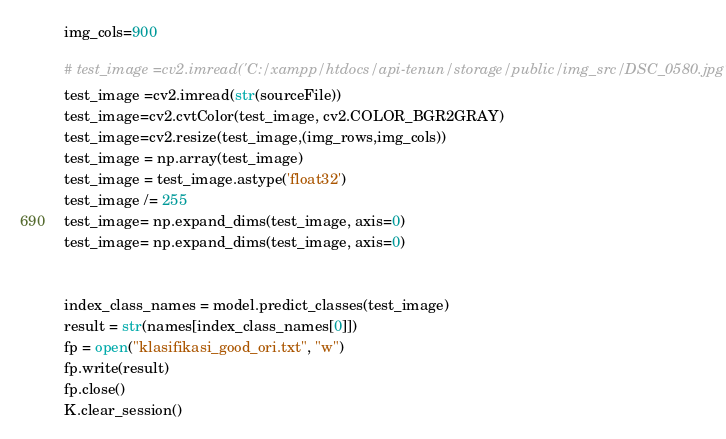<code> <loc_0><loc_0><loc_500><loc_500><_Python_>img_cols=900

# test_image =cv2.imread('C:/xampp/htdocs/api-tenun/storage/public/img_src/DSC_0580.jpg')
test_image =cv2.imread(str(sourceFile))
test_image=cv2.cvtColor(test_image, cv2.COLOR_BGR2GRAY)
test_image=cv2.resize(test_image,(img_rows,img_cols))
test_image = np.array(test_image)
test_image = test_image.astype('float32')
test_image /= 255
test_image= np.expand_dims(test_image, axis=0)
test_image= np.expand_dims(test_image, axis=0)


index_class_names = model.predict_classes(test_image)
result = str(names[index_class_names[0]])
fp = open("klasifikasi_good_ori.txt", "w")
fp.write(result)
fp.close()
K.clear_session()
</code> 